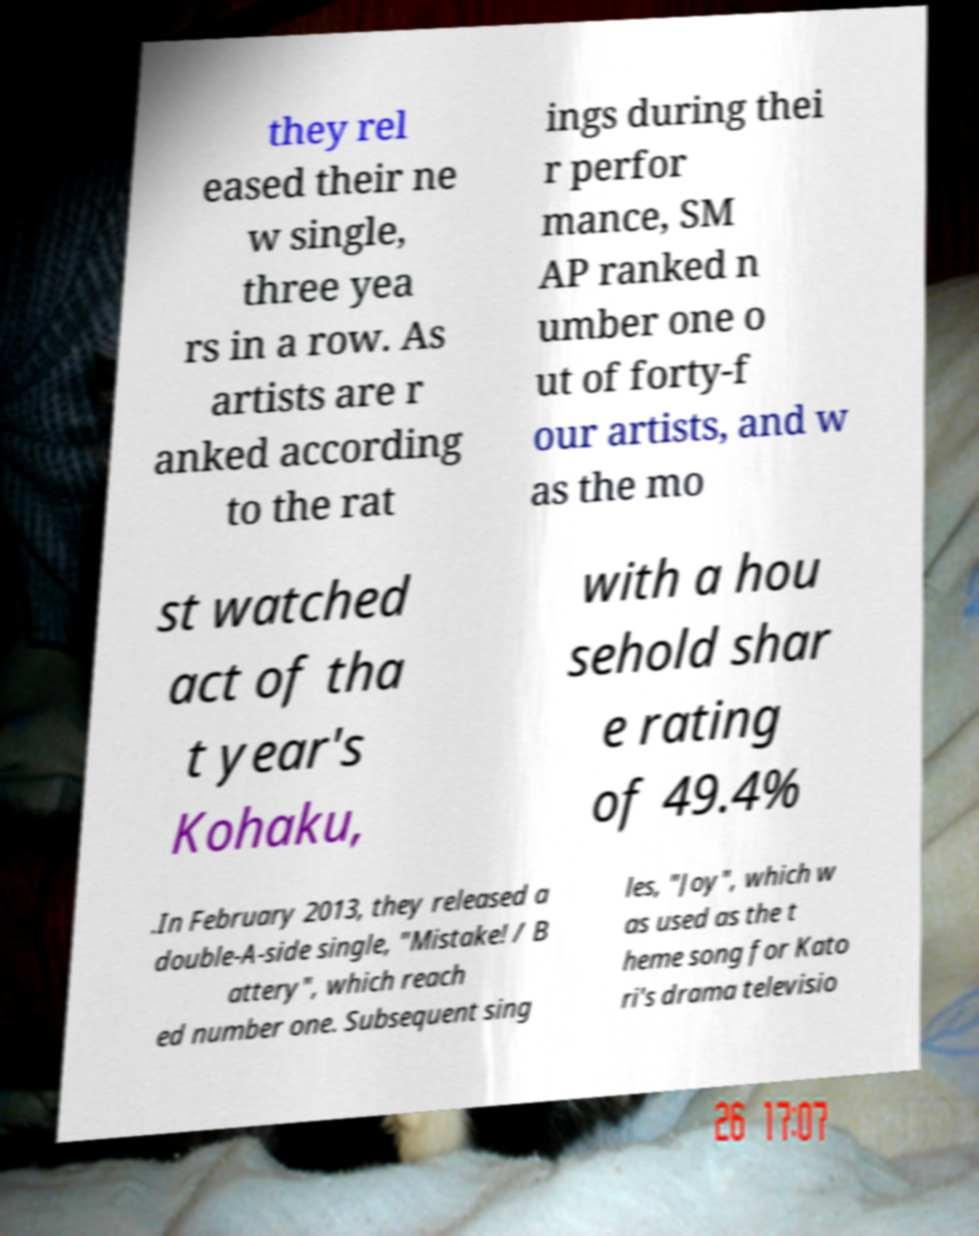For documentation purposes, I need the text within this image transcribed. Could you provide that? they rel eased their ne w single, three yea rs in a row. As artists are r anked according to the rat ings during thei r perfor mance, SM AP ranked n umber one o ut of forty-f our artists, and w as the mo st watched act of tha t year's Kohaku, with a hou sehold shar e rating of 49.4% .In February 2013, they released a double-A-side single, "Mistake! / B attery", which reach ed number one. Subsequent sing les, "Joy", which w as used as the t heme song for Kato ri's drama televisio 